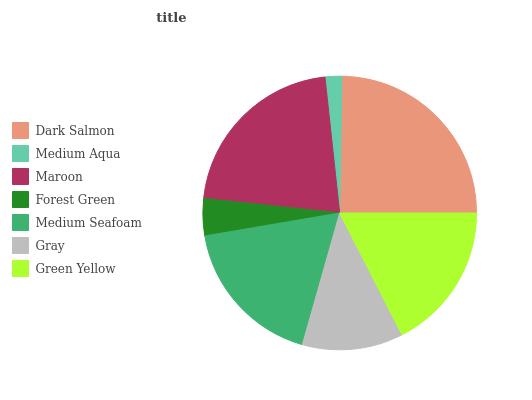Is Medium Aqua the minimum?
Answer yes or no. Yes. Is Dark Salmon the maximum?
Answer yes or no. Yes. Is Maroon the minimum?
Answer yes or no. No. Is Maroon the maximum?
Answer yes or no. No. Is Maroon greater than Medium Aqua?
Answer yes or no. Yes. Is Medium Aqua less than Maroon?
Answer yes or no. Yes. Is Medium Aqua greater than Maroon?
Answer yes or no. No. Is Maroon less than Medium Aqua?
Answer yes or no. No. Is Green Yellow the high median?
Answer yes or no. Yes. Is Green Yellow the low median?
Answer yes or no. Yes. Is Maroon the high median?
Answer yes or no. No. Is Maroon the low median?
Answer yes or no. No. 